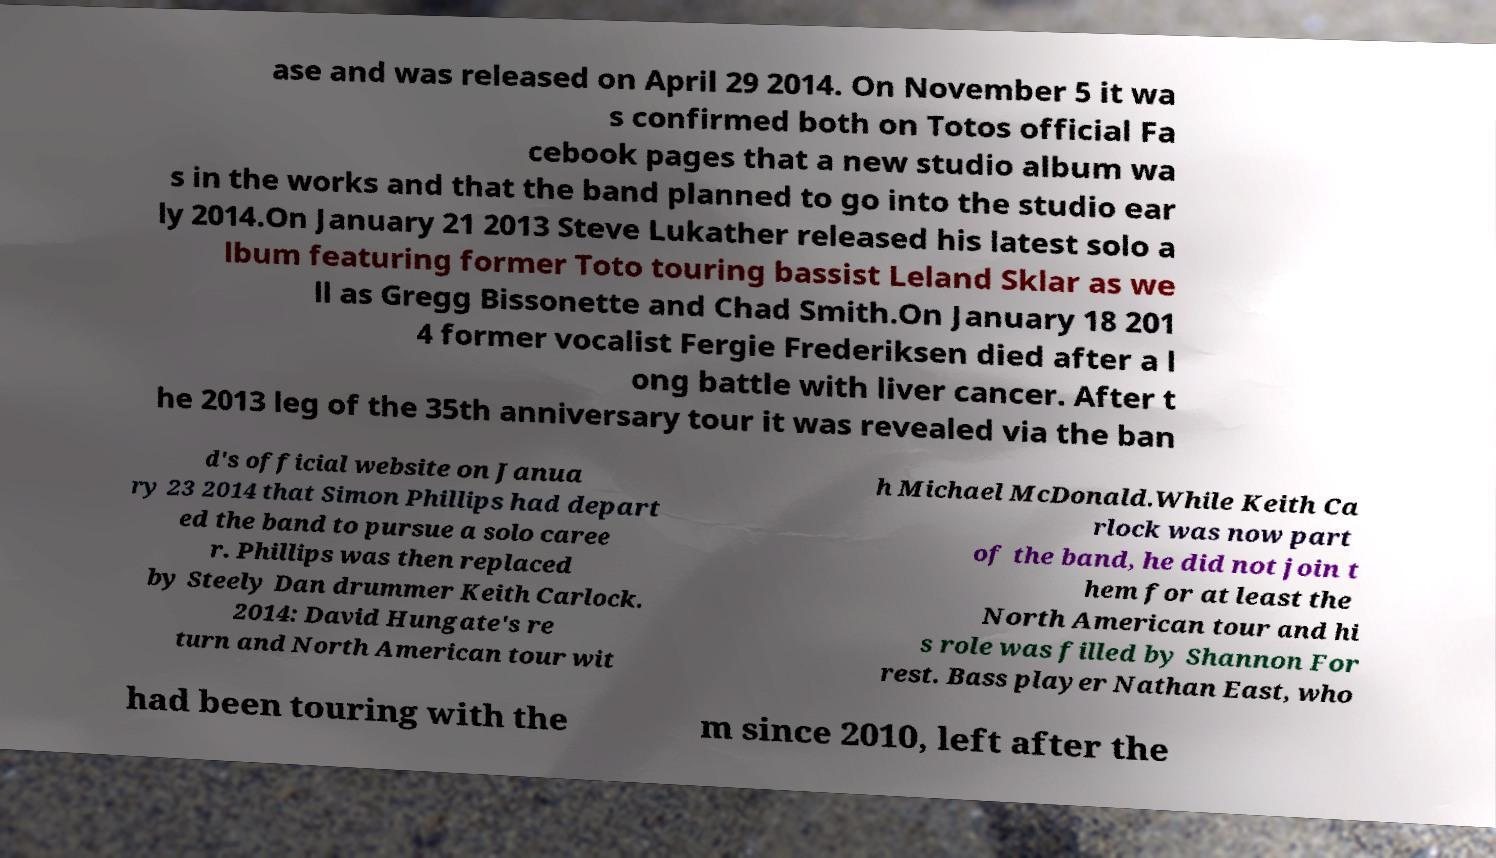There's text embedded in this image that I need extracted. Can you transcribe it verbatim? ase and was released on April 29 2014. On November 5 it wa s confirmed both on Totos official Fa cebook pages that a new studio album wa s in the works and that the band planned to go into the studio ear ly 2014.On January 21 2013 Steve Lukather released his latest solo a lbum featuring former Toto touring bassist Leland Sklar as we ll as Gregg Bissonette and Chad Smith.On January 18 201 4 former vocalist Fergie Frederiksen died after a l ong battle with liver cancer. After t he 2013 leg of the 35th anniversary tour it was revealed via the ban d's official website on Janua ry 23 2014 that Simon Phillips had depart ed the band to pursue a solo caree r. Phillips was then replaced by Steely Dan drummer Keith Carlock. 2014: David Hungate's re turn and North American tour wit h Michael McDonald.While Keith Ca rlock was now part of the band, he did not join t hem for at least the North American tour and hi s role was filled by Shannon For rest. Bass player Nathan East, who had been touring with the m since 2010, left after the 